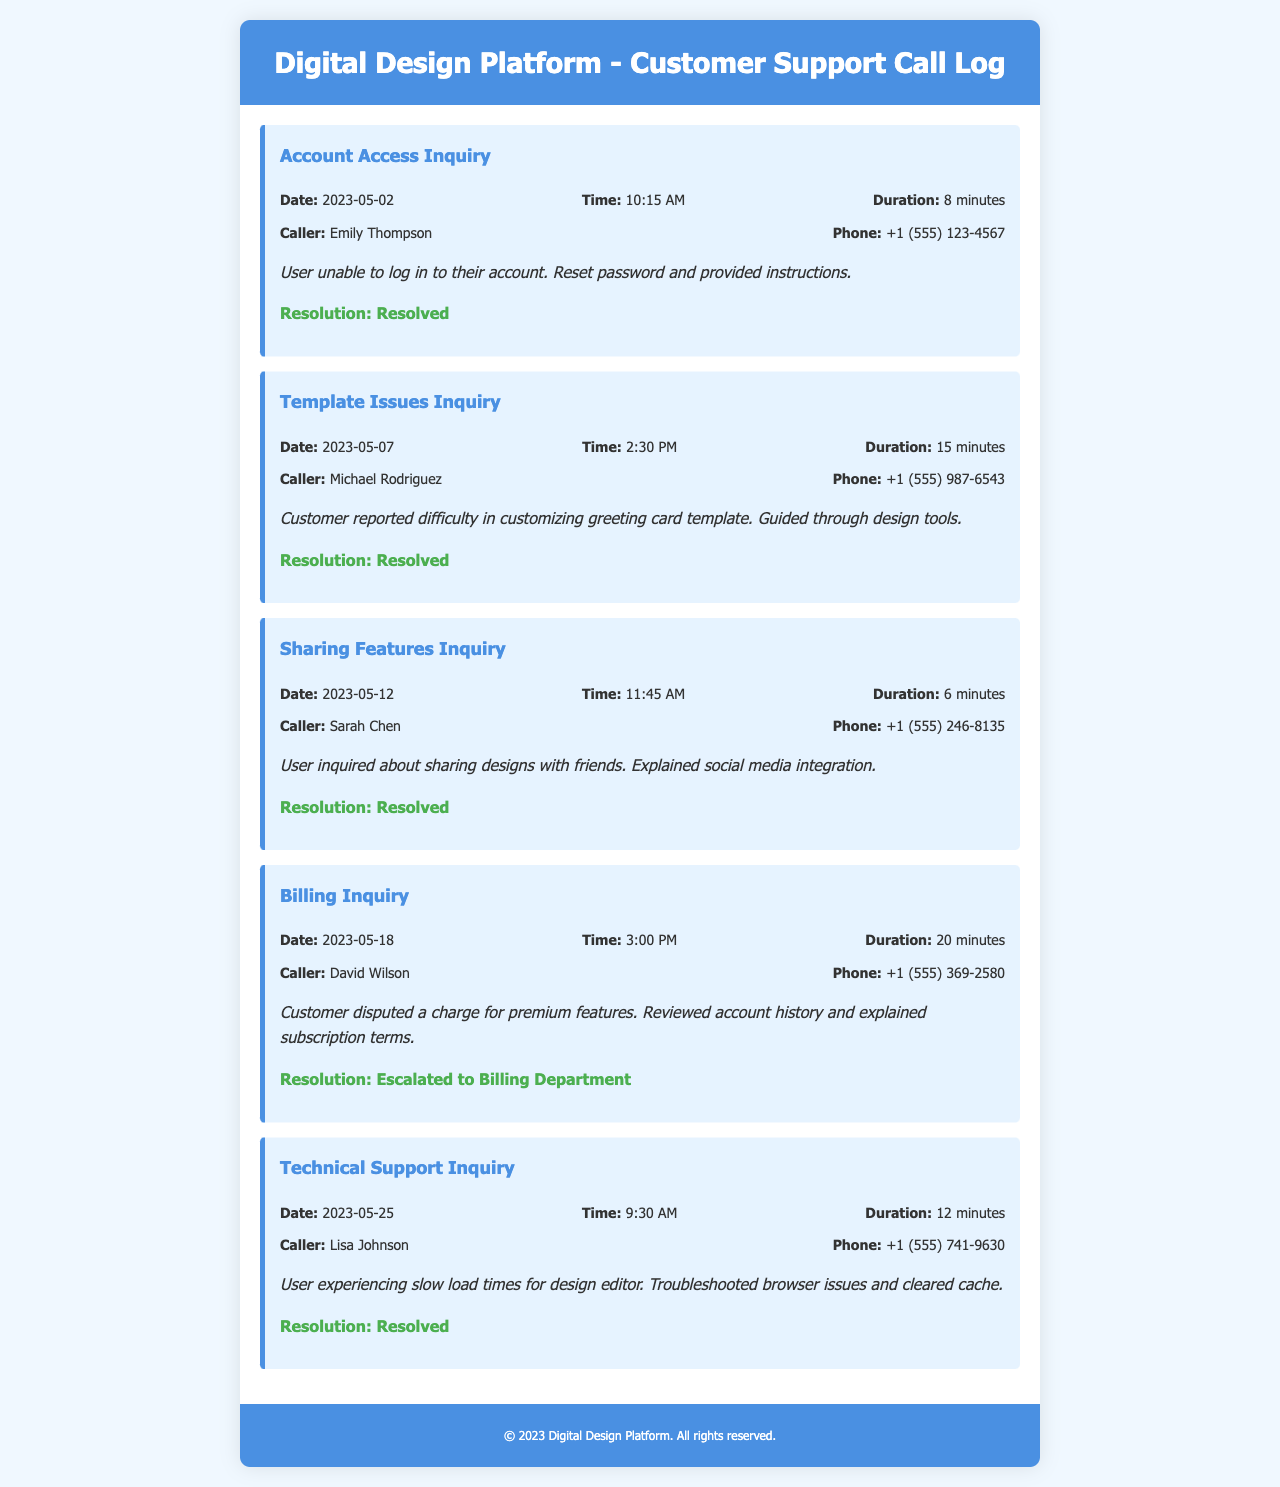What was the date of the Billing Inquiry? The Billing Inquiry was made on May 18, 2023, as specified in the call log.
Answer: May 18, 2023 Who was the caller for the Template Issues Inquiry? The call log states that Michael Rodriguez made the Template Issues Inquiry.
Answer: Michael Rodriguez How long was the duration of the Sharing Features Inquiry? The duration of the Sharing Features Inquiry is noted as 6 minutes in the document.
Answer: 6 minutes What was the resolution status of the Account Access Inquiry? The document indicates that the Account Access Inquiry was resolved.
Answer: Resolved On what date did the Technical Support Inquiry occur? The Technical Support Inquiry took place on May 25, 2023, according to the call log.
Answer: May 25, 2023 Which inquiry was escalated to the Billing Department? The document identifies that the Billing Inquiry was escalated to the Billing Department.
Answer: Billing Inquiry What issue did Lisa Johnson experience during the Technical Support Inquiry? The call log mentions that Lisa Johnson experienced slow load times for the design editor.
Answer: Slow load times What time did the Template Issues Inquiry take place? The Template Issues Inquiry occurred at 2:30 PM as listed in the call log.
Answer: 2:30 PM Who inquired about sharing designs with friends? According to the document, Sarah Chen inquired about sharing designs with friends.
Answer: Sarah Chen 